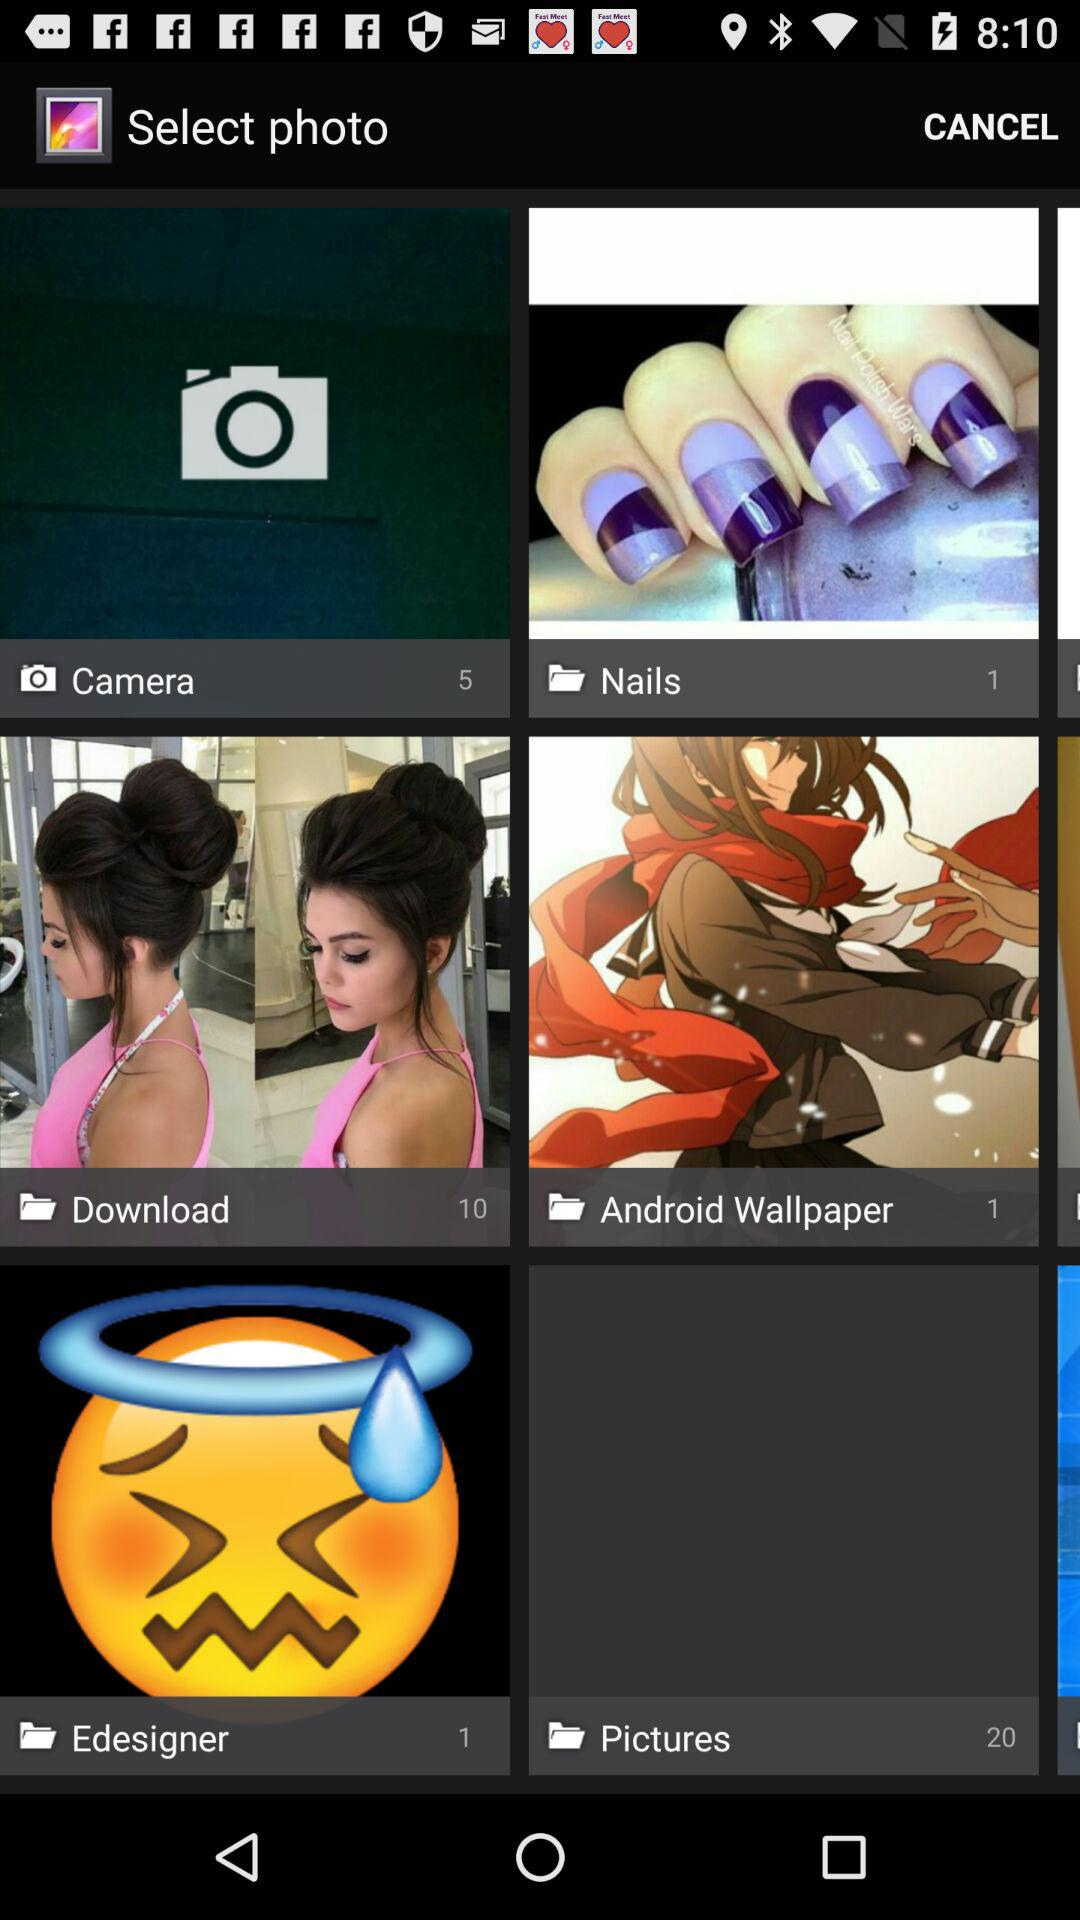How many images are there in the download folder? There are 10 images in the download folder. 